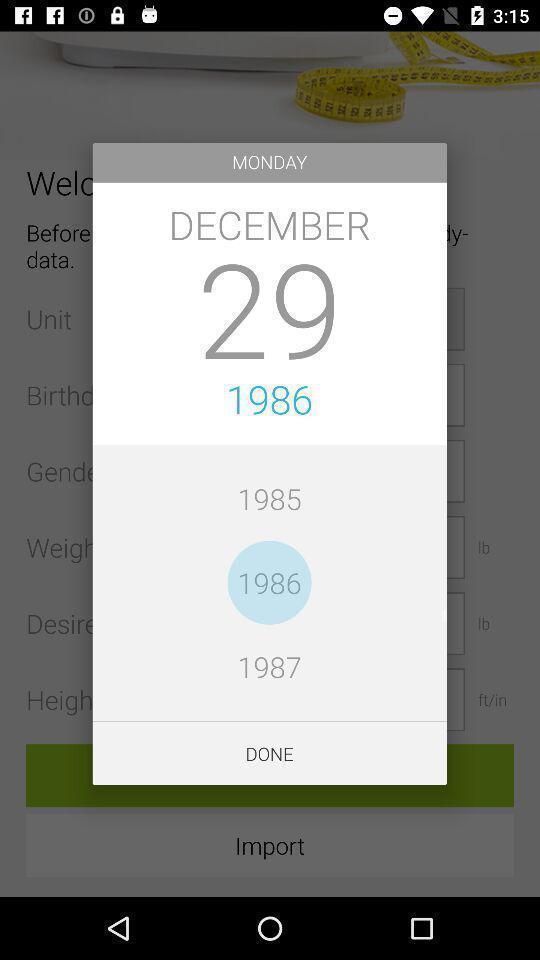What is the overall content of this screenshot? Pop-up displaying date day and year to set. 